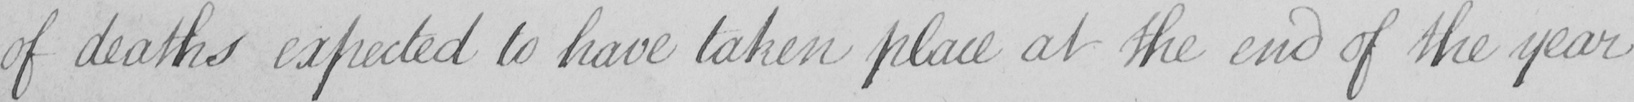Please transcribe the handwritten text in this image. of deaths expected to have taken place at the end of the year 